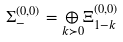<formula> <loc_0><loc_0><loc_500><loc_500>\Sigma _ { - } ^ { ( 0 , 0 ) } = \underset { k \succ 0 } { \oplus } \Xi _ { 1 - k } ^ { ( 0 , 0 ) }</formula> 